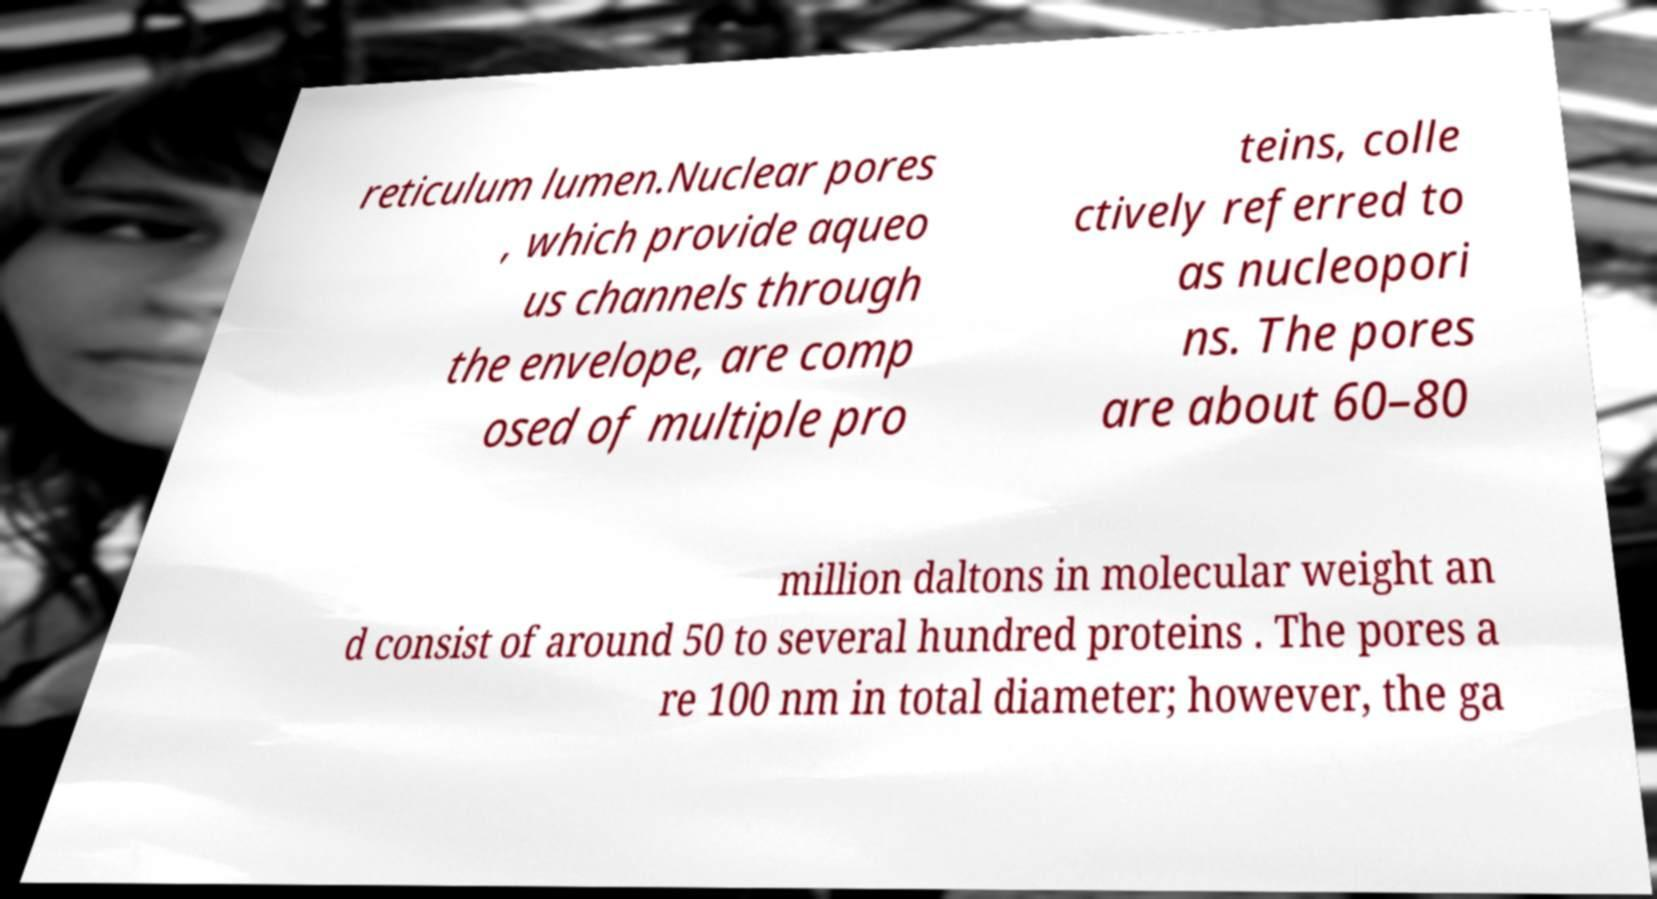Can you accurately transcribe the text from the provided image for me? reticulum lumen.Nuclear pores , which provide aqueo us channels through the envelope, are comp osed of multiple pro teins, colle ctively referred to as nucleopori ns. The pores are about 60–80 million daltons in molecular weight an d consist of around 50 to several hundred proteins . The pores a re 100 nm in total diameter; however, the ga 